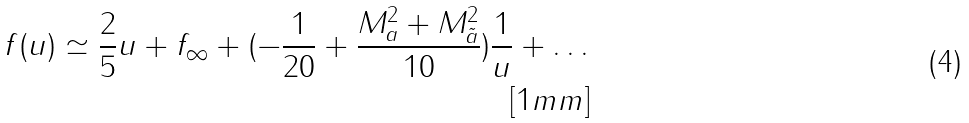<formula> <loc_0><loc_0><loc_500><loc_500>f ( u ) \simeq \frac { 2 } { 5 } u + f _ { \infty } + ( - \frac { 1 } { 2 0 } + \frac { M _ { a } ^ { 2 } + M _ { \tilde { a } } ^ { 2 } } { 1 0 } ) \frac { 1 } { u } + \dots \\ [ 1 m m ]</formula> 